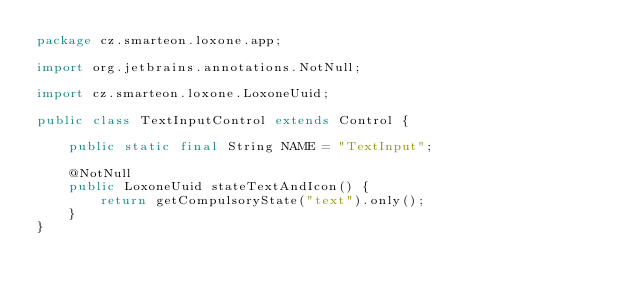Convert code to text. <code><loc_0><loc_0><loc_500><loc_500><_Java_>package cz.smarteon.loxone.app;

import org.jetbrains.annotations.NotNull;

import cz.smarteon.loxone.LoxoneUuid;

public class TextInputControl extends Control {

    public static final String NAME = "TextInput";

    @NotNull
    public LoxoneUuid stateTextAndIcon() {
        return getCompulsoryState("text").only();
    }
}
</code> 